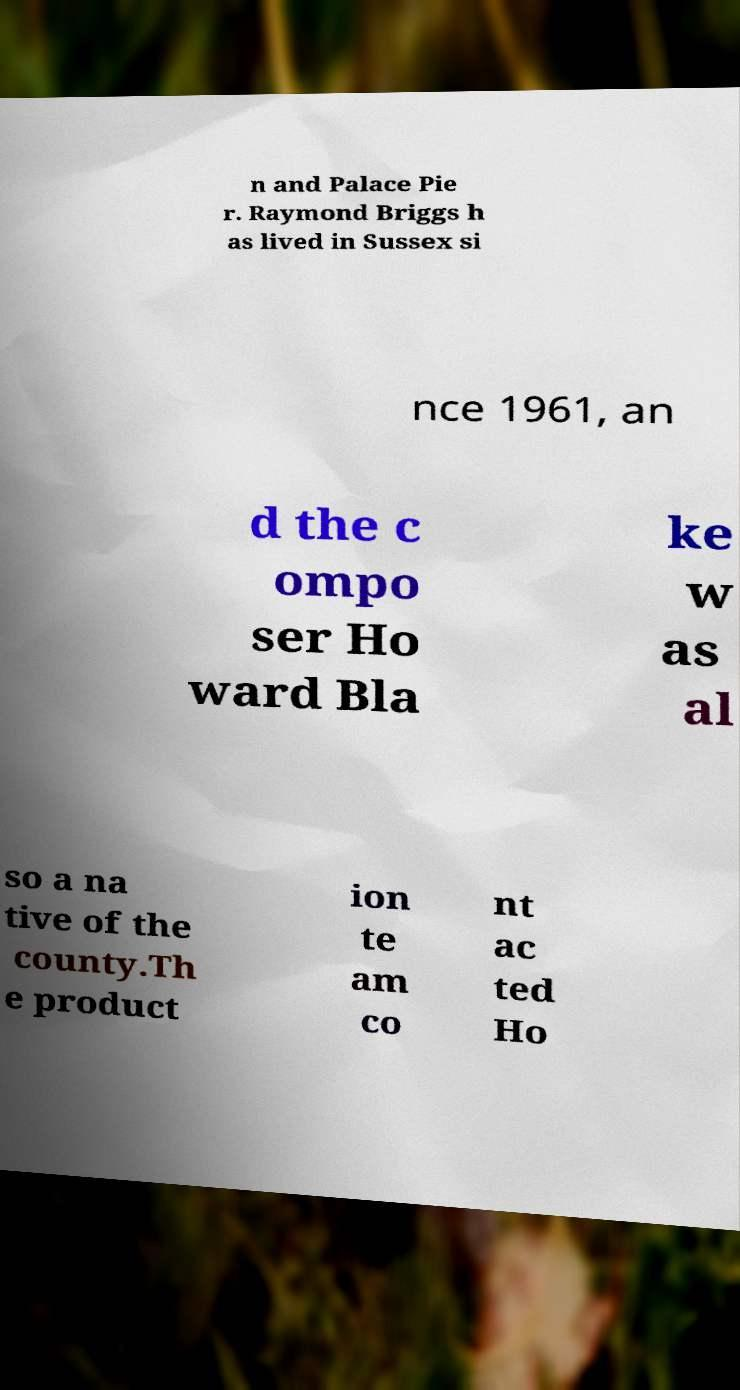Please identify and transcribe the text found in this image. n and Palace Pie r. Raymond Briggs h as lived in Sussex si nce 1961, an d the c ompo ser Ho ward Bla ke w as al so a na tive of the county.Th e product ion te am co nt ac ted Ho 